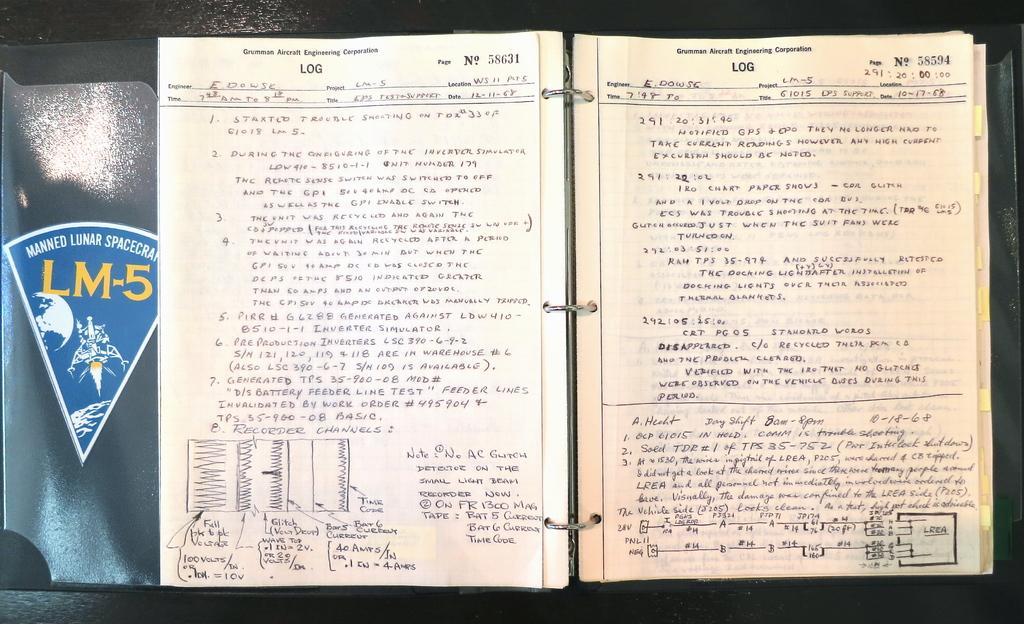<image>
Summarize the visual content of the image. a binder that has the word 'log' typed at the top of the page 